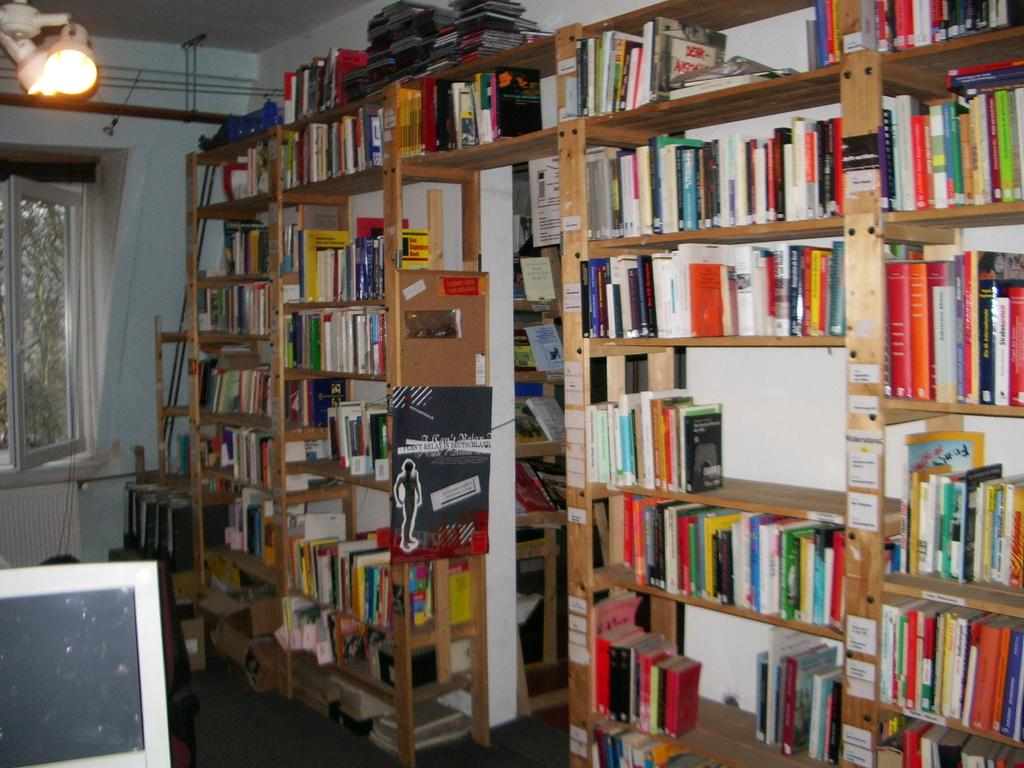What type of items can be seen in the racks in the image? There are books in the racks in the image. What electronic device is present in the image? There is a monitor in the image. What source of illumination is visible in the image? There is a light in the image. What can be seen in the background of the image? There is a window in the background of the image. Can you tell me where the bucket is located in the image? There is no bucket present in the image. What type of appliance can be seen interacting with the books in the image? There is no appliance interacting with the books in the image; only the monitor is present. 